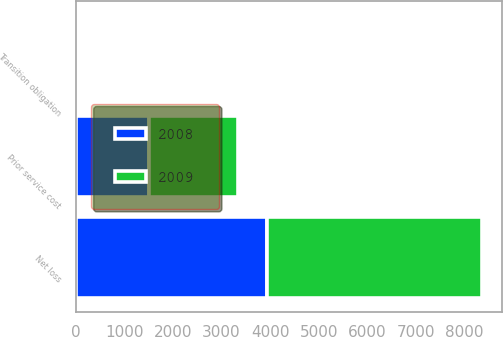Convert chart. <chart><loc_0><loc_0><loc_500><loc_500><stacked_bar_chart><ecel><fcel>Net loss<fcel>Prior service cost<fcel>Transition obligation<nl><fcel>2008<fcel>3935<fcel>1517<fcel>29<nl><fcel>2009<fcel>4427<fcel>1830<fcel>53<nl></chart> 